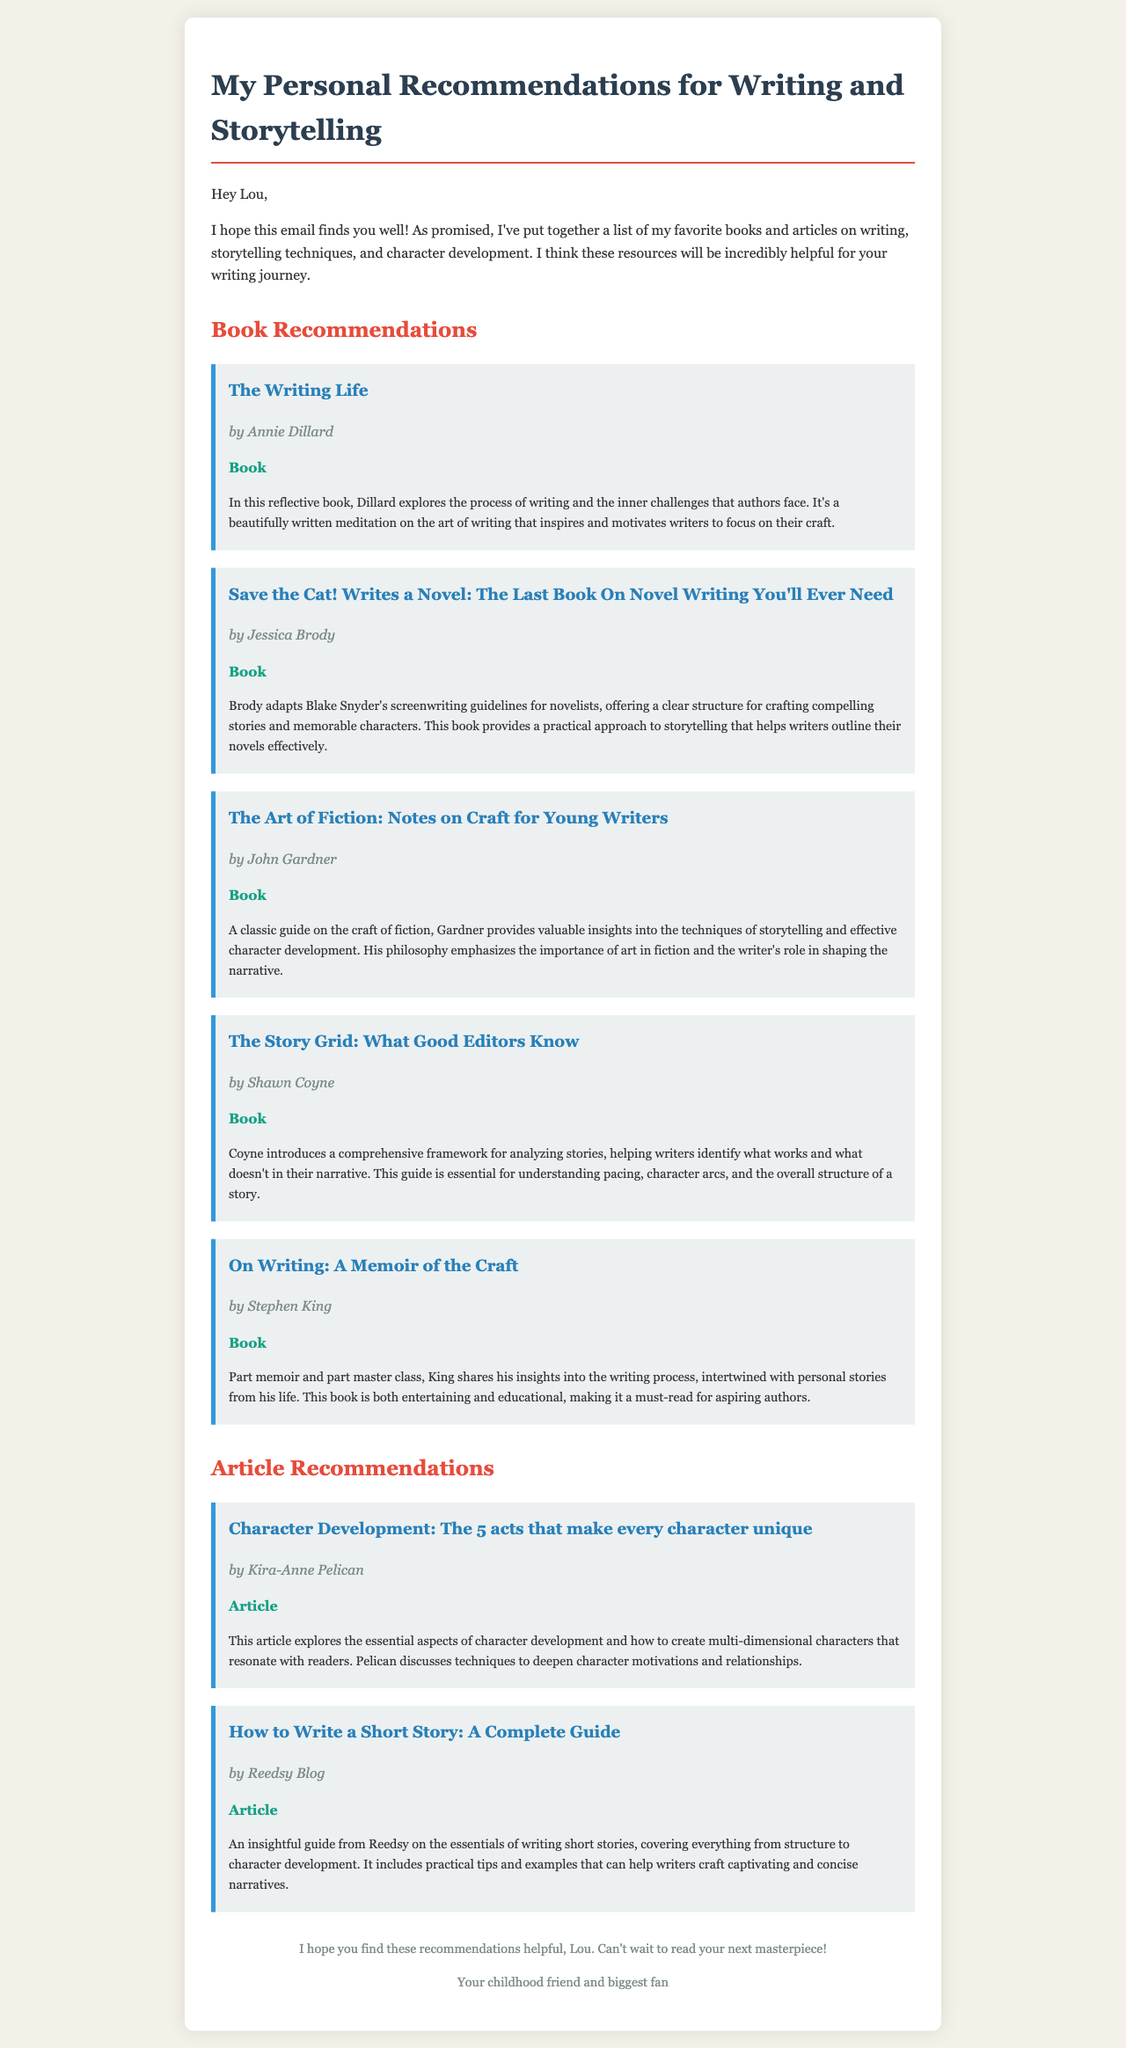What is the title of the first book recommended? The title of the first book is mentioned at the top of the book recommendations section.
Answer: The Writing Life Who is the author of "On Writing: A Memoir of the Craft"? The author is listed below the title in the recommendation section.
Answer: Stephen King How many articles are recommended in the document? The number of articles can be counted in the article recommendations section.
Answer: 2 What is a key theme discussed in "The Art of Fiction: Notes on Craft for Young Writers"? The theme can be inferred from the summary provided for this book.
Answer: Effective character development Who wrote the article on character development? The author's name is mentioned below the title of the article recommendation.
Answer: Kira-Anne Pelican Which book provides a guide for analyzing stories? This information is found in the summary of the relevant book recommendation.
Answer: The Story Grid What is the main focus of the article by Reedsy Blog? The focus can be understood from the article's title and summary.
Answer: Writing short stories What genre does Jessica Brody's book focus on? The genre is indicated in the title of the book since it refers specifically to novel writing.
Answer: Novel writing 